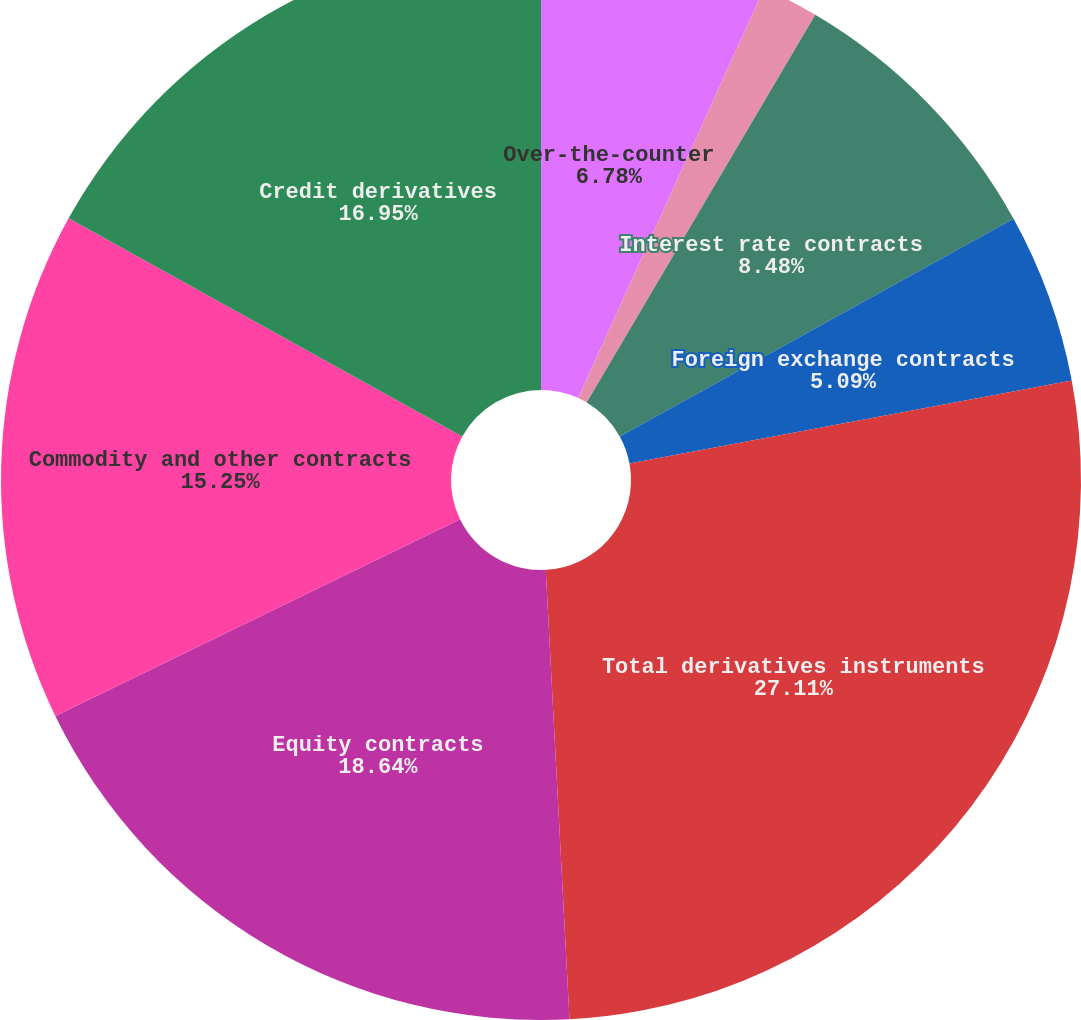Convert chart to OTSL. <chart><loc_0><loc_0><loc_500><loc_500><pie_chart><fcel>Over-the-counter<fcel>Cleared<fcel>Interest rate contracts<fcel>Foreign exchange contracts<fcel>Total derivatives instruments<fcel>Exchange traded<fcel>Equity contracts<fcel>Commodity and other contracts<fcel>Credit derivatives<nl><fcel>6.78%<fcel>1.7%<fcel>8.48%<fcel>5.09%<fcel>27.11%<fcel>0.0%<fcel>18.64%<fcel>15.25%<fcel>16.95%<nl></chart> 